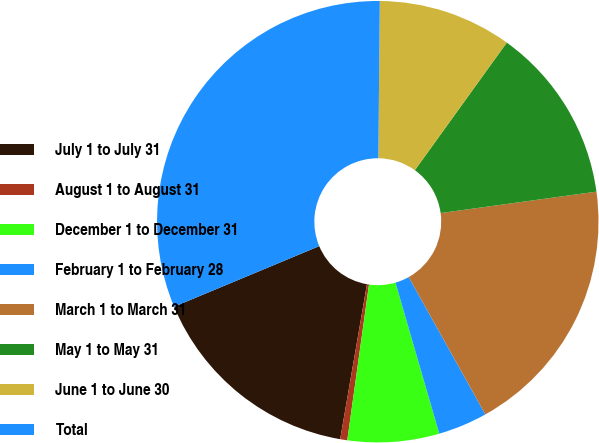Convert chart. <chart><loc_0><loc_0><loc_500><loc_500><pie_chart><fcel>July 1 to July 31<fcel>August 1 to August 31<fcel>December 1 to December 31<fcel>February 1 to February 28<fcel>March 1 to March 31<fcel>May 1 to May 31<fcel>June 1 to June 30<fcel>Total<nl><fcel>15.98%<fcel>0.52%<fcel>6.7%<fcel>3.61%<fcel>19.07%<fcel>12.89%<fcel>9.79%<fcel>31.44%<nl></chart> 